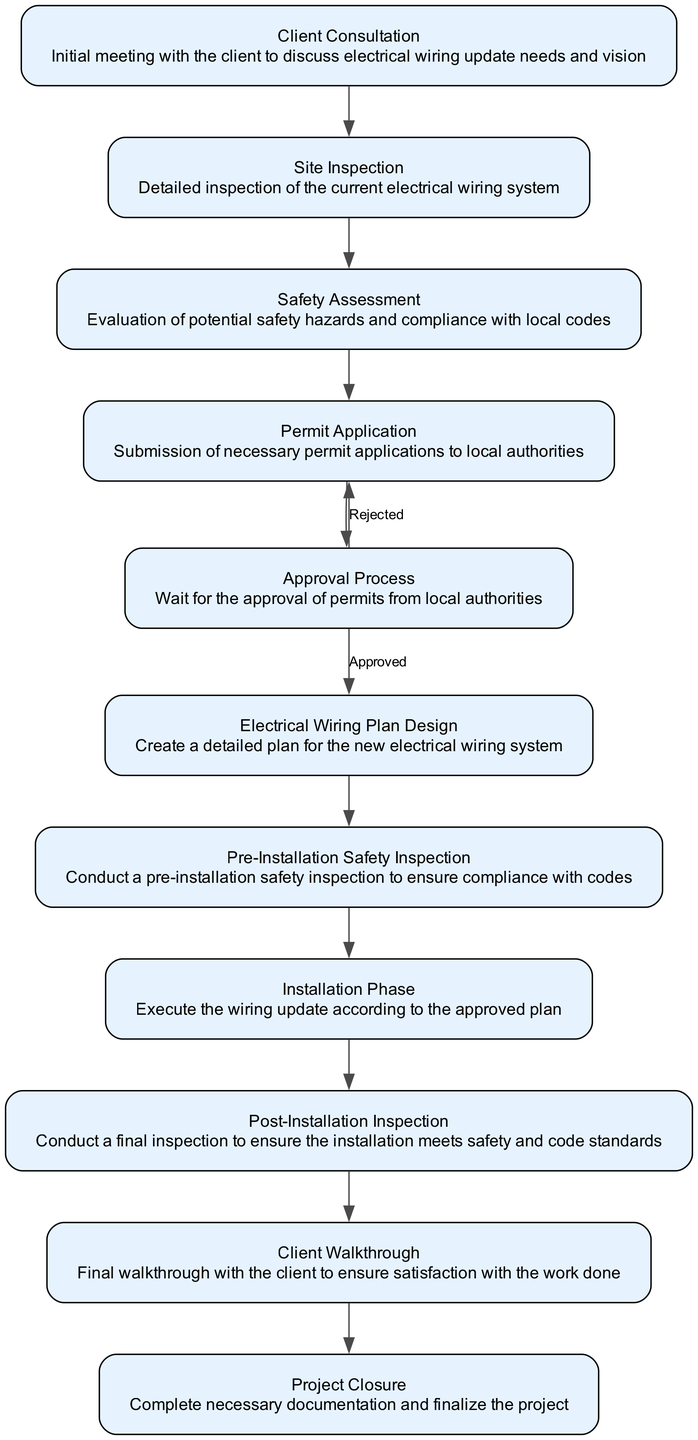What is the first step in the process? The diagram lists "Client Consultation" as the first node, indicating the initial interaction with the client to discuss their needs for the electrical wiring update.
Answer: Client Consultation How many steps are there in total? By counting all the nodes in the diagram, there are eleven distinct steps in the electrical wiring update process.
Answer: 11 What happens if the permit application is rejected? The diagram shows that if the permit application is rejected, the flow goes back to the "Permit Application" step to resubmit the application, indicating a looping process for approvals.
Answer: Permit Application What is the final step of the process? The last node in the diagram is "Project Closure," indicating the completion of all tasks and final documentation for the project.
Answer: Project Closure Which step follows the "Safety Assessment"? According to the flow chart, after "Safety Assessment," the next step is "Permit Application."
Answer: Permit Application What is conducted before the installation phase? The flow chart indicates that a "Pre-Installation Safety Inspection" is conducted prior to beginning the installation phase, ensuring compliance with safety codes.
Answer: Pre-Installation Safety Inspection What condition leads to the next step after "Approval Process"? The "Approval Process" leads to the next step "Electrical Wiring Plan Design" specifically if the permits are "Approved." If they are "Rejected," it loops back to "Permit Application."
Answer: Approved What is the purpose of the "Client Walkthrough"? The "Client Walkthrough" is designed to ensure client satisfaction with the electrical work completed, acting as a final review before project closure.
Answer: Client satisfaction How many inspections are included in the process? By analyzing the diagram, there are three inspections mentioned: "Pre-Installation Safety Inspection," "Post-Installation Inspection," and "Site Inspection," totaling three inspections throughout the process.
Answer: 3 